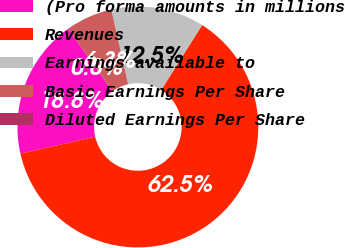<chart> <loc_0><loc_0><loc_500><loc_500><pie_chart><fcel>(Pro forma amounts in millions<fcel>Revenues<fcel>Earnings available to<fcel>Basic Earnings Per Share<fcel>Diluted Earnings Per Share<nl><fcel>18.75%<fcel>62.48%<fcel>12.5%<fcel>6.26%<fcel>0.01%<nl></chart> 